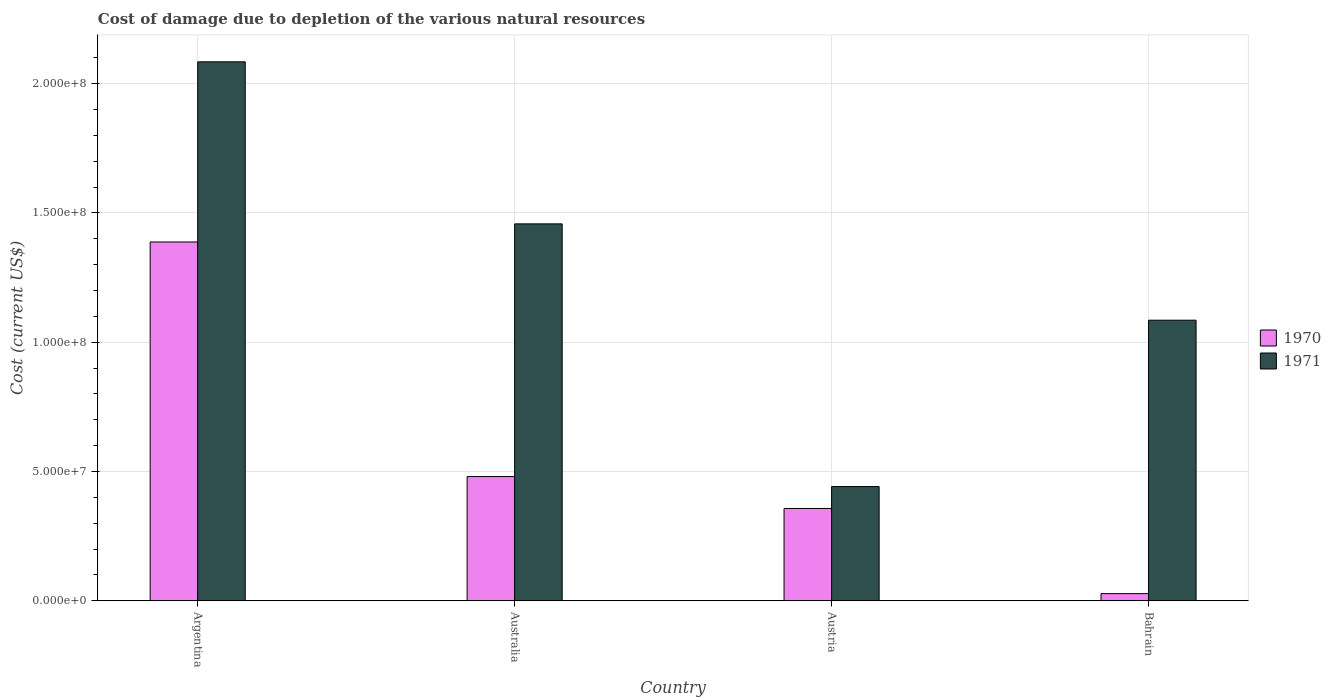Are the number of bars on each tick of the X-axis equal?
Provide a succinct answer. Yes. What is the cost of damage caused due to the depletion of various natural resources in 1971 in Austria?
Ensure brevity in your answer.  4.42e+07. Across all countries, what is the maximum cost of damage caused due to the depletion of various natural resources in 1970?
Ensure brevity in your answer.  1.39e+08. Across all countries, what is the minimum cost of damage caused due to the depletion of various natural resources in 1970?
Ensure brevity in your answer.  2.77e+06. In which country was the cost of damage caused due to the depletion of various natural resources in 1971 maximum?
Make the answer very short. Argentina. What is the total cost of damage caused due to the depletion of various natural resources in 1971 in the graph?
Your answer should be very brief. 5.07e+08. What is the difference between the cost of damage caused due to the depletion of various natural resources in 1970 in Argentina and that in Bahrain?
Provide a short and direct response. 1.36e+08. What is the difference between the cost of damage caused due to the depletion of various natural resources in 1971 in Australia and the cost of damage caused due to the depletion of various natural resources in 1970 in Austria?
Make the answer very short. 1.10e+08. What is the average cost of damage caused due to the depletion of various natural resources in 1970 per country?
Offer a very short reply. 5.63e+07. What is the difference between the cost of damage caused due to the depletion of various natural resources of/in 1970 and cost of damage caused due to the depletion of various natural resources of/in 1971 in Australia?
Your answer should be compact. -9.77e+07. What is the ratio of the cost of damage caused due to the depletion of various natural resources in 1970 in Argentina to that in Austria?
Your answer should be very brief. 3.89. Is the difference between the cost of damage caused due to the depletion of various natural resources in 1970 in Australia and Bahrain greater than the difference between the cost of damage caused due to the depletion of various natural resources in 1971 in Australia and Bahrain?
Your response must be concise. Yes. What is the difference between the highest and the second highest cost of damage caused due to the depletion of various natural resources in 1971?
Your response must be concise. -9.99e+07. What is the difference between the highest and the lowest cost of damage caused due to the depletion of various natural resources in 1971?
Offer a very short reply. 1.64e+08. In how many countries, is the cost of damage caused due to the depletion of various natural resources in 1971 greater than the average cost of damage caused due to the depletion of various natural resources in 1971 taken over all countries?
Make the answer very short. 2. Is the sum of the cost of damage caused due to the depletion of various natural resources in 1971 in Argentina and Australia greater than the maximum cost of damage caused due to the depletion of various natural resources in 1970 across all countries?
Ensure brevity in your answer.  Yes. What does the 1st bar from the left in Australia represents?
Your response must be concise. 1970. What is the difference between two consecutive major ticks on the Y-axis?
Keep it short and to the point. 5.00e+07. Are the values on the major ticks of Y-axis written in scientific E-notation?
Offer a terse response. Yes. Where does the legend appear in the graph?
Offer a very short reply. Center right. What is the title of the graph?
Your answer should be very brief. Cost of damage due to depletion of the various natural resources. What is the label or title of the Y-axis?
Your answer should be very brief. Cost (current US$). What is the Cost (current US$) in 1970 in Argentina?
Offer a very short reply. 1.39e+08. What is the Cost (current US$) of 1971 in Argentina?
Make the answer very short. 2.08e+08. What is the Cost (current US$) in 1970 in Australia?
Your response must be concise. 4.80e+07. What is the Cost (current US$) in 1971 in Australia?
Provide a succinct answer. 1.46e+08. What is the Cost (current US$) in 1970 in Austria?
Give a very brief answer. 3.57e+07. What is the Cost (current US$) in 1971 in Austria?
Give a very brief answer. 4.42e+07. What is the Cost (current US$) in 1970 in Bahrain?
Offer a terse response. 2.77e+06. What is the Cost (current US$) in 1971 in Bahrain?
Provide a succinct answer. 1.09e+08. Across all countries, what is the maximum Cost (current US$) in 1970?
Give a very brief answer. 1.39e+08. Across all countries, what is the maximum Cost (current US$) of 1971?
Offer a terse response. 2.08e+08. Across all countries, what is the minimum Cost (current US$) in 1970?
Your response must be concise. 2.77e+06. Across all countries, what is the minimum Cost (current US$) of 1971?
Offer a terse response. 4.42e+07. What is the total Cost (current US$) of 1970 in the graph?
Offer a terse response. 2.25e+08. What is the total Cost (current US$) of 1971 in the graph?
Give a very brief answer. 5.07e+08. What is the difference between the Cost (current US$) of 1970 in Argentina and that in Australia?
Your answer should be compact. 9.07e+07. What is the difference between the Cost (current US$) of 1971 in Argentina and that in Australia?
Make the answer very short. 6.27e+07. What is the difference between the Cost (current US$) of 1970 in Argentina and that in Austria?
Offer a very short reply. 1.03e+08. What is the difference between the Cost (current US$) of 1971 in Argentina and that in Austria?
Your response must be concise. 1.64e+08. What is the difference between the Cost (current US$) of 1970 in Argentina and that in Bahrain?
Provide a succinct answer. 1.36e+08. What is the difference between the Cost (current US$) of 1971 in Argentina and that in Bahrain?
Provide a succinct answer. 9.99e+07. What is the difference between the Cost (current US$) in 1970 in Australia and that in Austria?
Keep it short and to the point. 1.23e+07. What is the difference between the Cost (current US$) of 1971 in Australia and that in Austria?
Your answer should be compact. 1.02e+08. What is the difference between the Cost (current US$) in 1970 in Australia and that in Bahrain?
Keep it short and to the point. 4.53e+07. What is the difference between the Cost (current US$) in 1971 in Australia and that in Bahrain?
Provide a short and direct response. 3.73e+07. What is the difference between the Cost (current US$) of 1970 in Austria and that in Bahrain?
Your answer should be very brief. 3.29e+07. What is the difference between the Cost (current US$) of 1971 in Austria and that in Bahrain?
Your answer should be compact. -6.43e+07. What is the difference between the Cost (current US$) of 1970 in Argentina and the Cost (current US$) of 1971 in Australia?
Make the answer very short. -7.00e+06. What is the difference between the Cost (current US$) of 1970 in Argentina and the Cost (current US$) of 1971 in Austria?
Offer a very short reply. 9.46e+07. What is the difference between the Cost (current US$) of 1970 in Argentina and the Cost (current US$) of 1971 in Bahrain?
Provide a short and direct response. 3.03e+07. What is the difference between the Cost (current US$) in 1970 in Australia and the Cost (current US$) in 1971 in Austria?
Ensure brevity in your answer.  3.86e+06. What is the difference between the Cost (current US$) in 1970 in Australia and the Cost (current US$) in 1971 in Bahrain?
Ensure brevity in your answer.  -6.05e+07. What is the difference between the Cost (current US$) in 1970 in Austria and the Cost (current US$) in 1971 in Bahrain?
Offer a terse response. -7.28e+07. What is the average Cost (current US$) of 1970 per country?
Provide a short and direct response. 5.63e+07. What is the average Cost (current US$) in 1971 per country?
Your response must be concise. 1.27e+08. What is the difference between the Cost (current US$) of 1970 and Cost (current US$) of 1971 in Argentina?
Your response must be concise. -6.97e+07. What is the difference between the Cost (current US$) of 1970 and Cost (current US$) of 1971 in Australia?
Your answer should be compact. -9.77e+07. What is the difference between the Cost (current US$) of 1970 and Cost (current US$) of 1971 in Austria?
Your answer should be compact. -8.48e+06. What is the difference between the Cost (current US$) in 1970 and Cost (current US$) in 1971 in Bahrain?
Your answer should be very brief. -1.06e+08. What is the ratio of the Cost (current US$) of 1970 in Argentina to that in Australia?
Offer a terse response. 2.89. What is the ratio of the Cost (current US$) in 1971 in Argentina to that in Australia?
Provide a succinct answer. 1.43. What is the ratio of the Cost (current US$) in 1970 in Argentina to that in Austria?
Offer a very short reply. 3.89. What is the ratio of the Cost (current US$) in 1971 in Argentina to that in Austria?
Your answer should be very brief. 4.72. What is the ratio of the Cost (current US$) in 1970 in Argentina to that in Bahrain?
Provide a succinct answer. 50.09. What is the ratio of the Cost (current US$) of 1971 in Argentina to that in Bahrain?
Give a very brief answer. 1.92. What is the ratio of the Cost (current US$) in 1970 in Australia to that in Austria?
Make the answer very short. 1.35. What is the ratio of the Cost (current US$) in 1971 in Australia to that in Austria?
Provide a short and direct response. 3.3. What is the ratio of the Cost (current US$) of 1970 in Australia to that in Bahrain?
Give a very brief answer. 17.34. What is the ratio of the Cost (current US$) of 1971 in Australia to that in Bahrain?
Offer a very short reply. 1.34. What is the ratio of the Cost (current US$) of 1970 in Austria to that in Bahrain?
Your answer should be very brief. 12.89. What is the ratio of the Cost (current US$) of 1971 in Austria to that in Bahrain?
Give a very brief answer. 0.41. What is the difference between the highest and the second highest Cost (current US$) in 1970?
Give a very brief answer. 9.07e+07. What is the difference between the highest and the second highest Cost (current US$) of 1971?
Provide a succinct answer. 6.27e+07. What is the difference between the highest and the lowest Cost (current US$) in 1970?
Offer a terse response. 1.36e+08. What is the difference between the highest and the lowest Cost (current US$) in 1971?
Make the answer very short. 1.64e+08. 